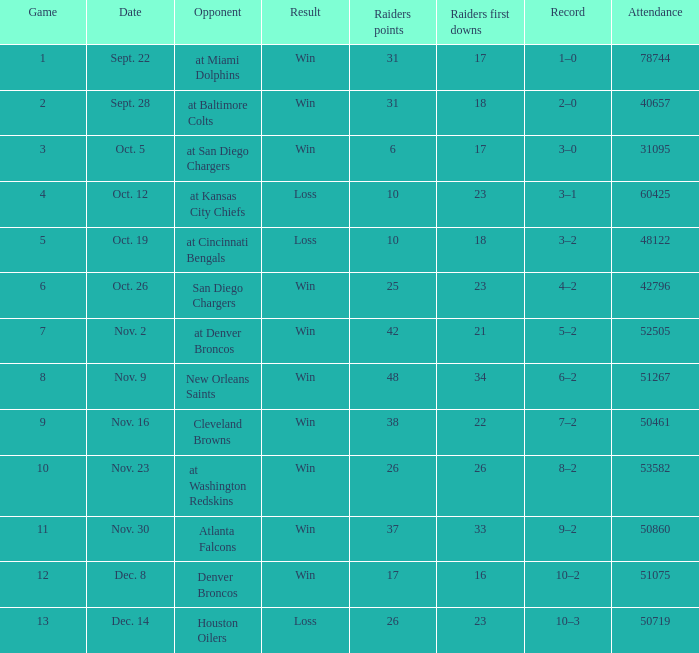How many opponents played 1 game with a result win? 21.0. 